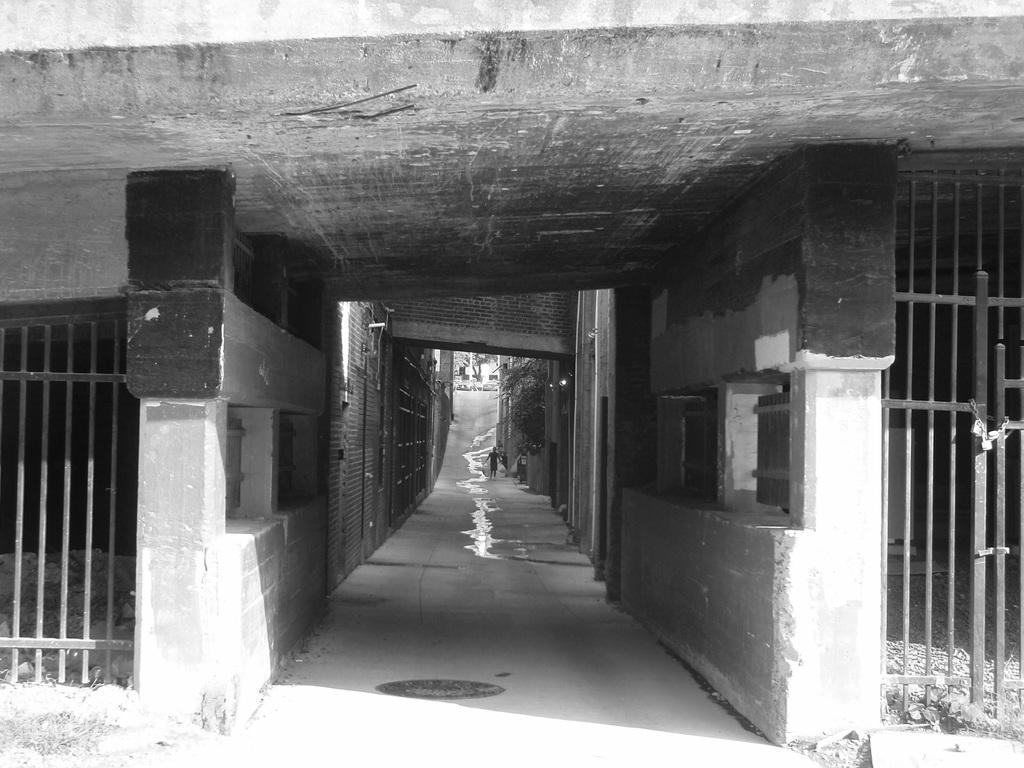What type of street is depicted in the image? There is a narrow street in the image. Are there any specific features of the street? Yes, there is a gate made of iron on the right side of the street. What type of jelly can be seen hanging from the gate in the image? There is no jelly present in the image, and therefore no such activity can be observed. 